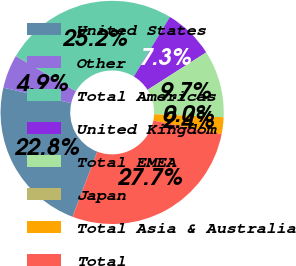Convert chart. <chart><loc_0><loc_0><loc_500><loc_500><pie_chart><fcel>United States<fcel>Other<fcel>Total Americas<fcel>United Kingdom<fcel>Total EMEA<fcel>Japan<fcel>Total Asia & Australia<fcel>Total<nl><fcel>22.79%<fcel>4.87%<fcel>25.22%<fcel>7.3%<fcel>9.73%<fcel>0.0%<fcel>2.43%<fcel>27.65%<nl></chart> 